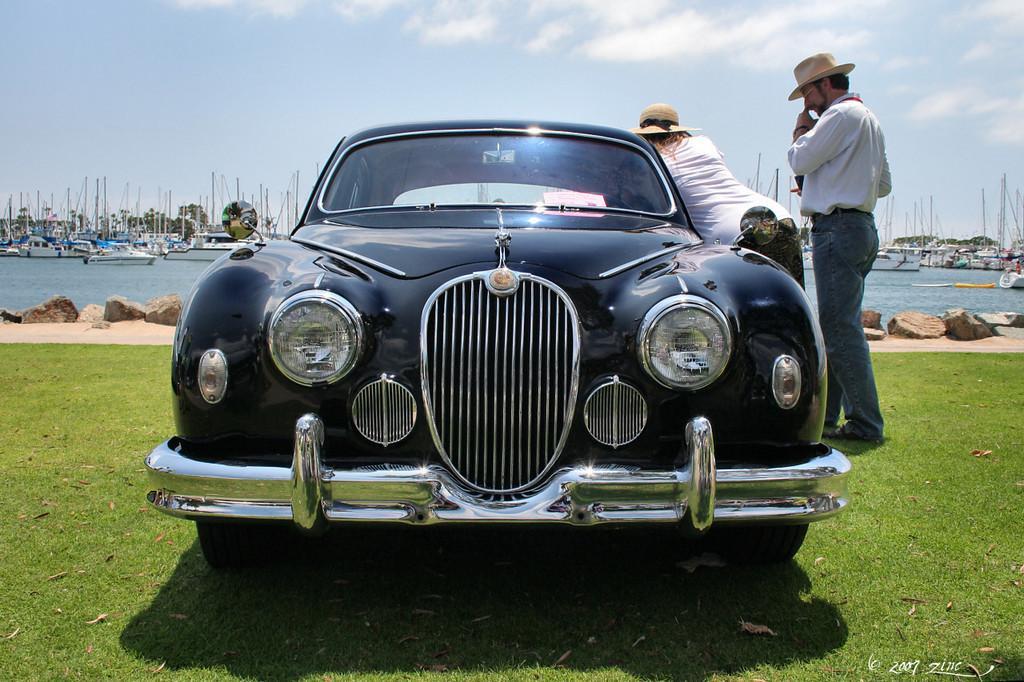Could you give a brief overview of what you see in this image? In this picture I can see there is a car, it has a windshield, headlights and there are mirrors and there is a woman wearing a shirt and a hat, the man is also wearing a white shirt and hat and in the backdrop I can see there rocks, sea and boats in the sea. The sky is clear. 